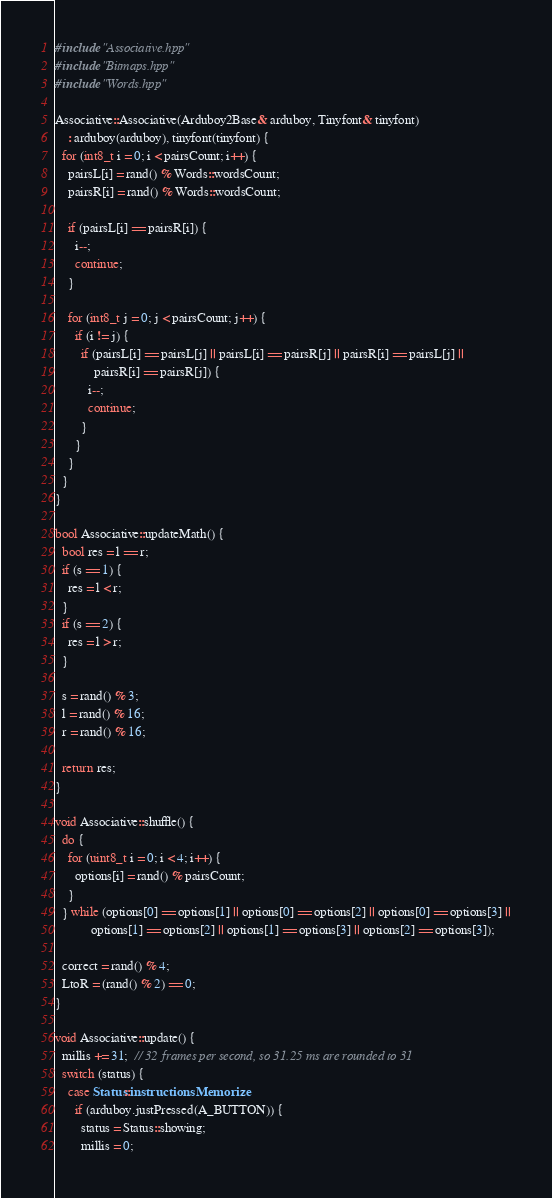Convert code to text. <code><loc_0><loc_0><loc_500><loc_500><_C++_>#include "Associative.hpp"
#include "Bitmaps.hpp"
#include "Words.hpp"

Associative::Associative(Arduboy2Base& arduboy, Tinyfont& tinyfont)
    : arduboy(arduboy), tinyfont(tinyfont) {
  for (int8_t i = 0; i < pairsCount; i++) {
    pairsL[i] = rand() % Words::wordsCount;
    pairsR[i] = rand() % Words::wordsCount;

    if (pairsL[i] == pairsR[i]) {
      i--;
      continue;
    }

    for (int8_t j = 0; j < pairsCount; j++) {
      if (i != j) {
        if (pairsL[i] == pairsL[j] || pairsL[i] == pairsR[j] || pairsR[i] == pairsL[j] ||
            pairsR[i] == pairsR[j]) {
          i--;
          continue;
        }
      }
    }
  }
}

bool Associative::updateMath() {
  bool res = l == r;
  if (s == 1) {
    res = l < r;
  }
  if (s == 2) {
    res = l > r;
  }

  s = rand() % 3;
  l = rand() % 16;
  r = rand() % 16;

  return res;
}

void Associative::shuffle() {
  do {
    for (uint8_t i = 0; i < 4; i++) {
      options[i] = rand() % pairsCount;
    }
  } while (options[0] == options[1] || options[0] == options[2] || options[0] == options[3] ||
           options[1] == options[2] || options[1] == options[3] || options[2] == options[3]);

  correct = rand() % 4;
  LtoR = (rand() % 2) == 0;
}

void Associative::update() {
  millis += 31;  // 32 frames per second, so 31.25 ms are rounded to 31
  switch (status) {
    case Status::instructionsMemorize:
      if (arduboy.justPressed(A_BUTTON)) {
        status = Status::showing;
        millis = 0;</code> 